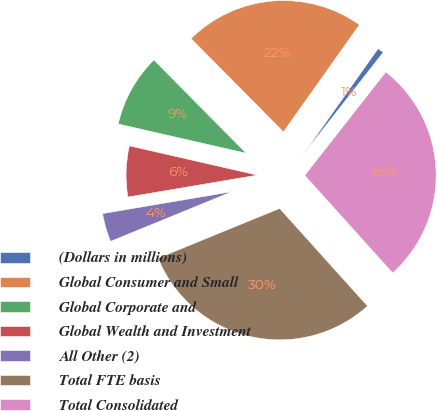Convert chart. <chart><loc_0><loc_0><loc_500><loc_500><pie_chart><fcel>(Dollars in millions)<fcel>Global Consumer and Small<fcel>Global Corporate and<fcel>Global Wealth and Investment<fcel>All Other (2)<fcel>Total FTE basis<fcel>Total Consolidated<nl><fcel>0.77%<fcel>22.24%<fcel>9.0%<fcel>6.25%<fcel>3.51%<fcel>30.49%<fcel>27.75%<nl></chart> 